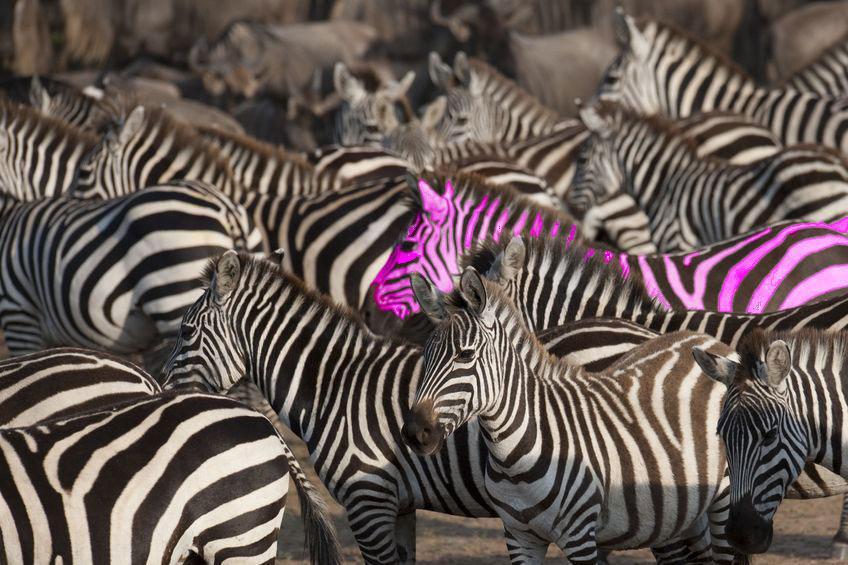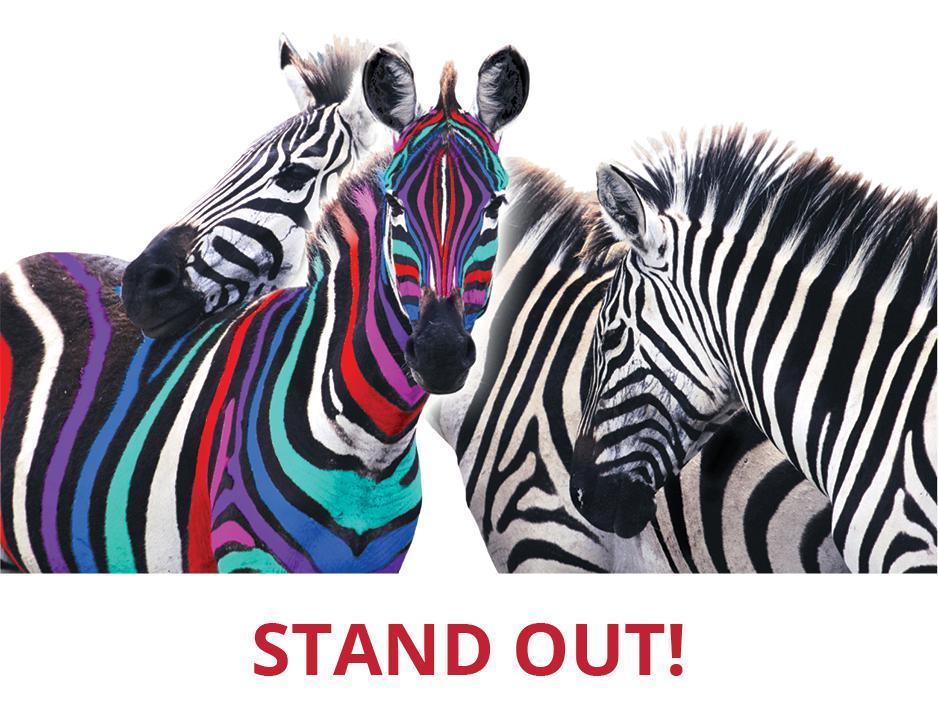The first image is the image on the left, the second image is the image on the right. Analyze the images presented: Is the assertion "The left image includes one zebra with only violet tint added, standing on the far right with its body turned leftward." valid? Answer yes or no. Yes. The first image is the image on the left, the second image is the image on the right. Evaluate the accuracy of this statement regarding the images: "In the left image, there is one zebra with black and purple stripes.". Is it true? Answer yes or no. Yes. 